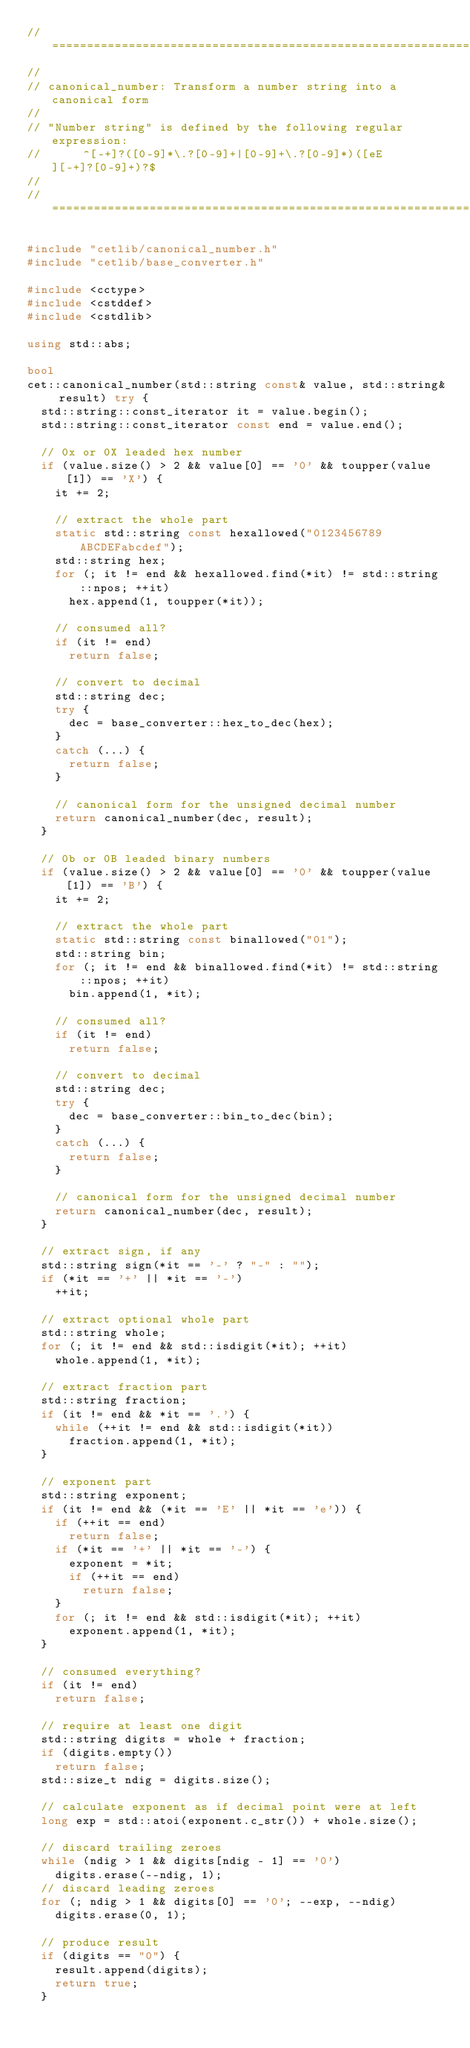Convert code to text. <code><loc_0><loc_0><loc_500><loc_500><_C++_>// ======================================================================
//
// canonical_number: Transform a number string into a canonical form
//
// "Number string" is defined by the following regular expression:
//      ^[-+]?([0-9]*\.?[0-9]+|[0-9]+\.?[0-9]*)([eE][-+]?[0-9]+)?$
//
// ======================================================================

#include "cetlib/canonical_number.h"
#include "cetlib/base_converter.h"

#include <cctype>
#include <cstddef>
#include <cstdlib>

using std::abs;

bool
cet::canonical_number(std::string const& value, std::string& result) try {
  std::string::const_iterator it = value.begin();
  std::string::const_iterator const end = value.end();

  // 0x or 0X leaded hex number
  if (value.size() > 2 && value[0] == '0' && toupper(value[1]) == 'X') {
    it += 2;

    // extract the whole part
    static std::string const hexallowed("0123456789ABCDEFabcdef");
    std::string hex;
    for (; it != end && hexallowed.find(*it) != std::string::npos; ++it)
      hex.append(1, toupper(*it));

    // consumed all?
    if (it != end)
      return false;

    // convert to decimal
    std::string dec;
    try {
      dec = base_converter::hex_to_dec(hex);
    }
    catch (...) {
      return false;
    }

    // canonical form for the unsigned decimal number
    return canonical_number(dec, result);
  }

  // 0b or 0B leaded binary numbers
  if (value.size() > 2 && value[0] == '0' && toupper(value[1]) == 'B') {
    it += 2;

    // extract the whole part
    static std::string const binallowed("01");
    std::string bin;
    for (; it != end && binallowed.find(*it) != std::string::npos; ++it)
      bin.append(1, *it);

    // consumed all?
    if (it != end)
      return false;

    // convert to decimal
    std::string dec;
    try {
      dec = base_converter::bin_to_dec(bin);
    }
    catch (...) {
      return false;
    }

    // canonical form for the unsigned decimal number
    return canonical_number(dec, result);
  }

  // extract sign, if any
  std::string sign(*it == '-' ? "-" : "");
  if (*it == '+' || *it == '-')
    ++it;

  // extract optional whole part
  std::string whole;
  for (; it != end && std::isdigit(*it); ++it)
    whole.append(1, *it);

  // extract fraction part
  std::string fraction;
  if (it != end && *it == '.') {
    while (++it != end && std::isdigit(*it))
      fraction.append(1, *it);
  }

  // exponent part
  std::string exponent;
  if (it != end && (*it == 'E' || *it == 'e')) {
    if (++it == end)
      return false;
    if (*it == '+' || *it == '-') {
      exponent = *it;
      if (++it == end)
        return false;
    }
    for (; it != end && std::isdigit(*it); ++it)
      exponent.append(1, *it);
  }

  // consumed everything?
  if (it != end)
    return false;

  // require at least one digit
  std::string digits = whole + fraction;
  if (digits.empty())
    return false;
  std::size_t ndig = digits.size();

  // calculate exponent as if decimal point were at left
  long exp = std::atoi(exponent.c_str()) + whole.size();

  // discard trailing zeroes
  while (ndig > 1 && digits[ndig - 1] == '0')
    digits.erase(--ndig, 1);
  // discard leading zeroes
  for (; ndig > 1 && digits[0] == '0'; --exp, --ndig)
    digits.erase(0, 1);

  // produce result
  if (digits == "0") {
    result.append(digits);
    return true;
  }</code> 